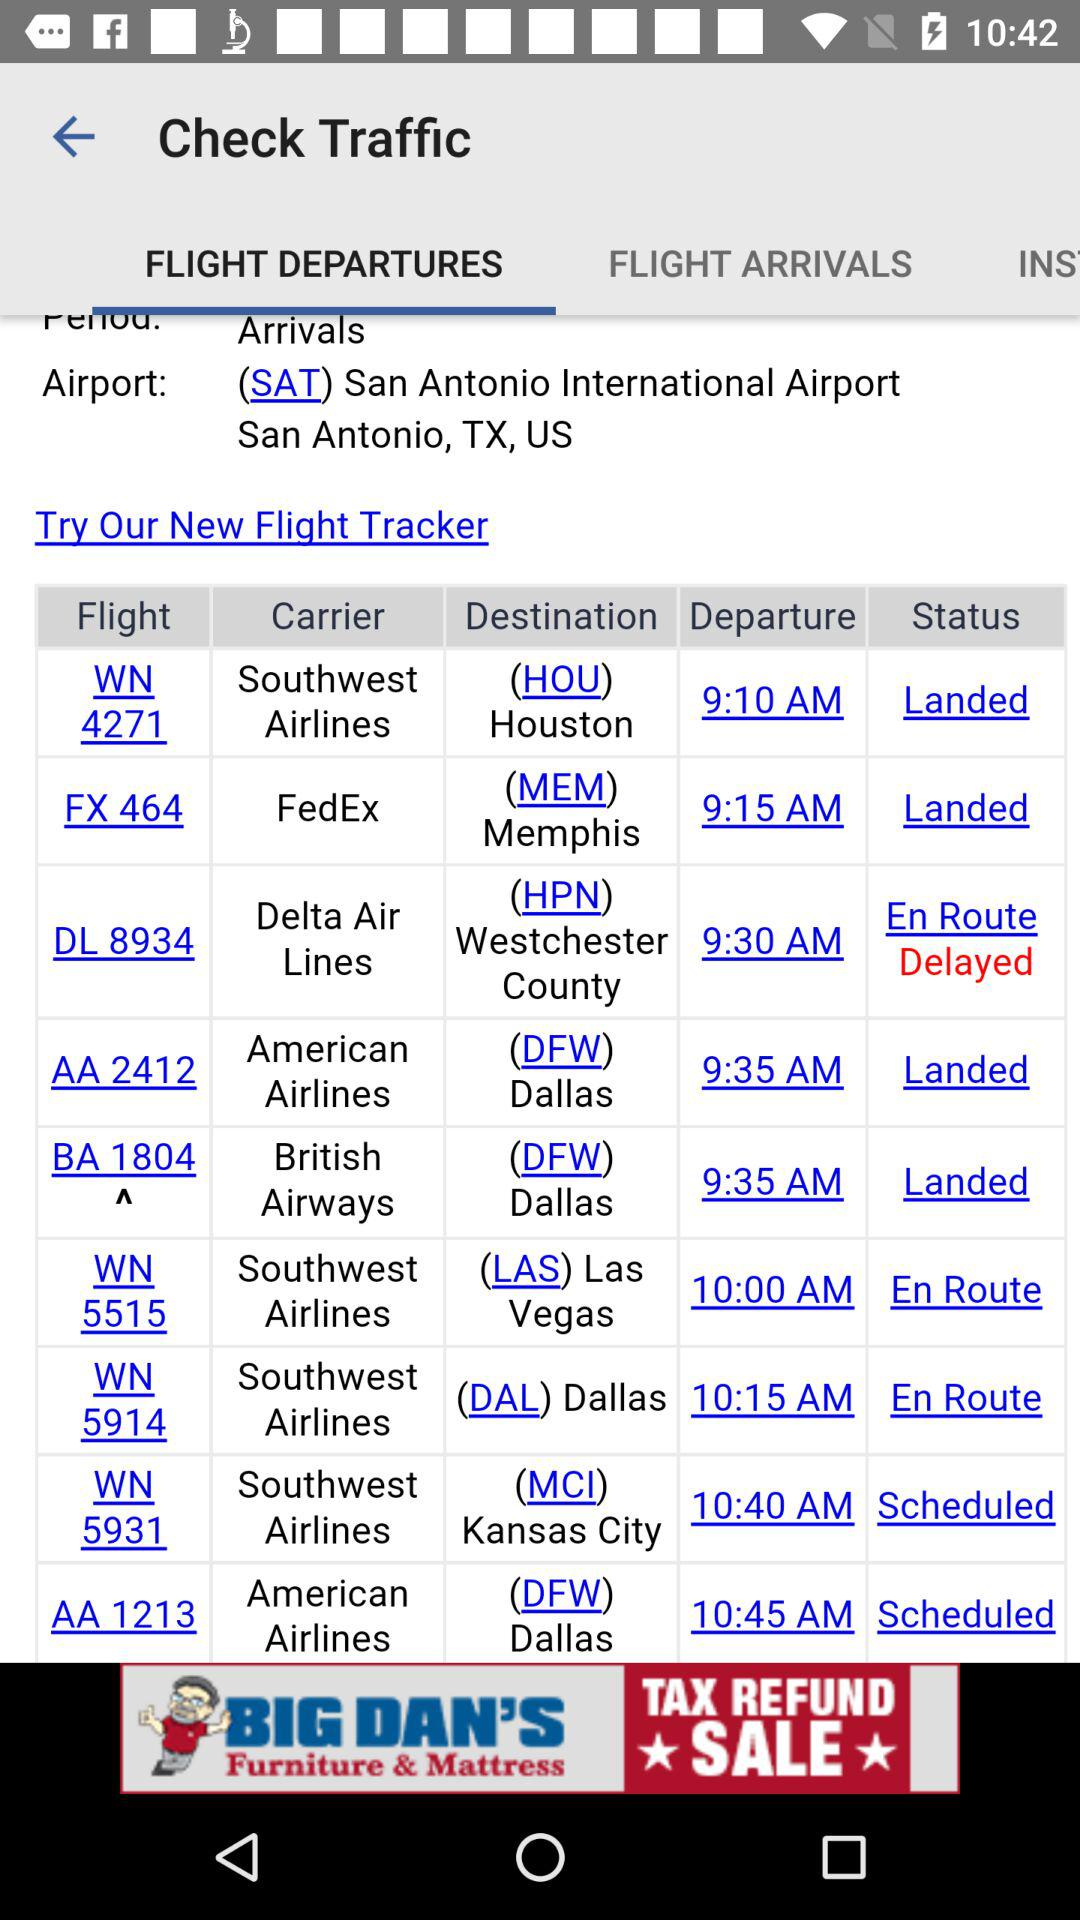What is the name of the airport? The name of the airport is San Antonio International Airport. 